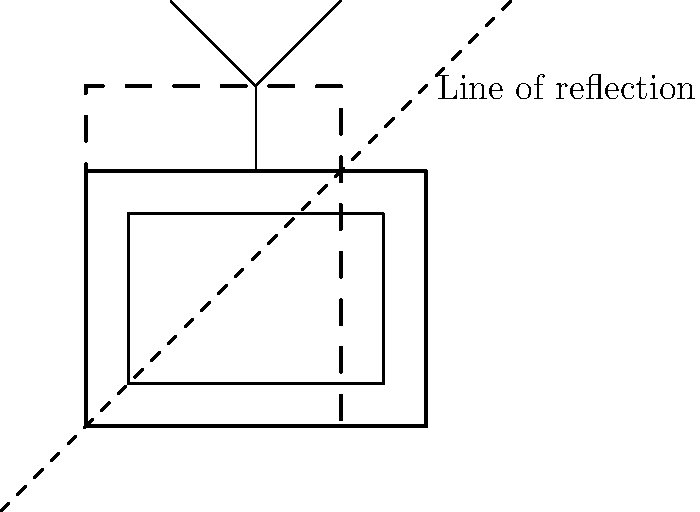In your favorite Hindi TV drama, a geometric representation of a TV set is shown on a coordinate plane. The TV is reflected across a line passing through the points $(-1,-1)$ and $(5,5)$. If the original TV's bottom-left corner is at $(0,0)$ and its top-right corner is at $(4,3)$, what are the coordinates of the reflected TV's bottom-left corner? Let's approach this step-by-step:

1) The line of reflection passes through $(-1,-1)$ and $(5,5)$. This is the line $y = x$.

2) To reflect a point $(x,y)$ across the line $y = x$, we swap its $x$ and $y$ coordinates. So $(x,y)$ becomes $(y,x)$.

3) The bottom-left corner of the original TV is at $(0,0)$. When reflected across $y = x$, it remains at $(0,0)$.

4) The top-right corner of the original TV is at $(4,3)$. When reflected across $y = x$, it becomes $(3,4)$.

5) Now, we need to find the bottom-left corner of this reflected TV. It will have the x-coordinate of the original bottom-left corner and the y-coordinate of the original top-right corner.

6) Therefore, the bottom-left corner of the reflected TV will be at $(0,4)$.
Answer: $(0,4)$ 